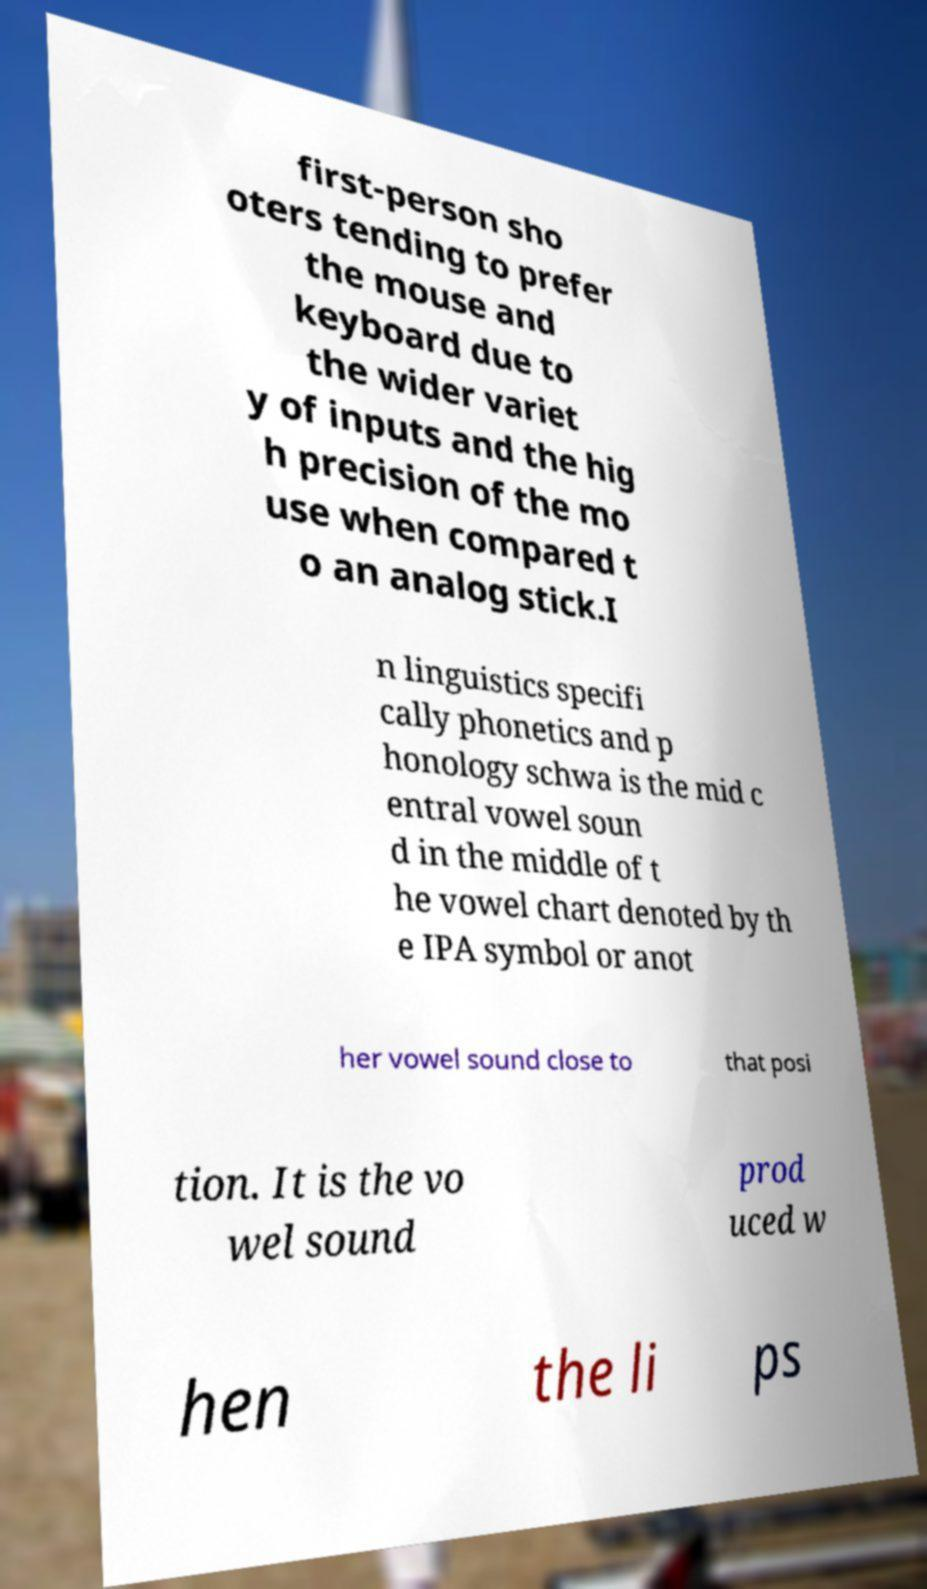Could you extract and type out the text from this image? first-person sho oters tending to prefer the mouse and keyboard due to the wider variet y of inputs and the hig h precision of the mo use when compared t o an analog stick.I n linguistics specifi cally phonetics and p honology schwa is the mid c entral vowel soun d in the middle of t he vowel chart denoted by th e IPA symbol or anot her vowel sound close to that posi tion. It is the vo wel sound prod uced w hen the li ps 